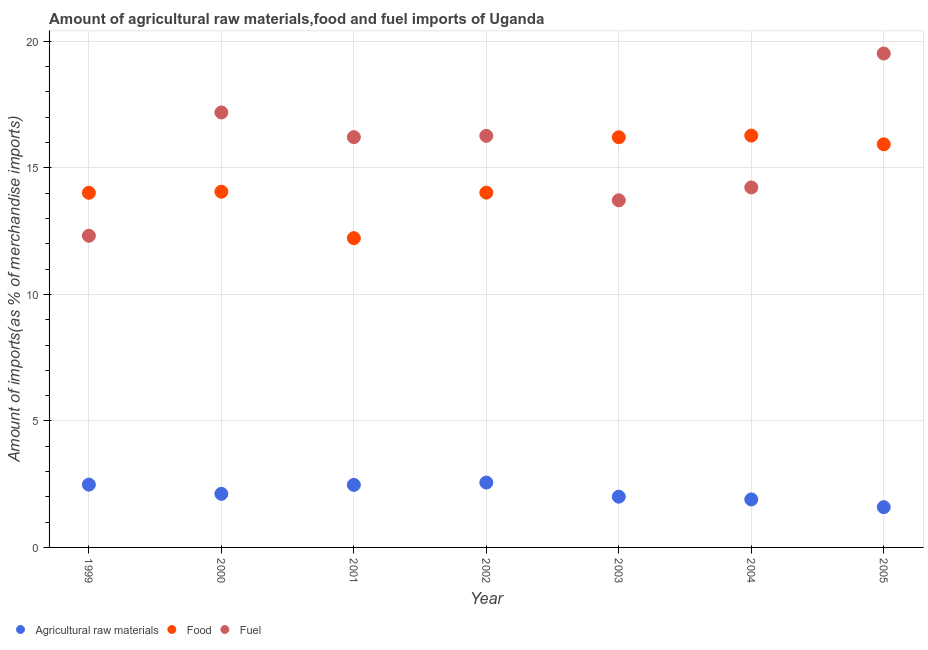Is the number of dotlines equal to the number of legend labels?
Keep it short and to the point. Yes. What is the percentage of fuel imports in 1999?
Offer a very short reply. 12.32. Across all years, what is the maximum percentage of food imports?
Offer a very short reply. 16.28. Across all years, what is the minimum percentage of fuel imports?
Your answer should be very brief. 12.32. In which year was the percentage of raw materials imports minimum?
Offer a terse response. 2005. What is the total percentage of fuel imports in the graph?
Ensure brevity in your answer.  109.46. What is the difference between the percentage of fuel imports in 1999 and that in 2001?
Give a very brief answer. -3.9. What is the difference between the percentage of raw materials imports in 2002 and the percentage of food imports in 2005?
Your answer should be very brief. -13.37. What is the average percentage of fuel imports per year?
Give a very brief answer. 15.64. In the year 2002, what is the difference between the percentage of raw materials imports and percentage of fuel imports?
Ensure brevity in your answer.  -13.7. In how many years, is the percentage of fuel imports greater than 15 %?
Your answer should be very brief. 4. What is the ratio of the percentage of fuel imports in 2000 to that in 2002?
Your answer should be very brief. 1.06. What is the difference between the highest and the second highest percentage of fuel imports?
Your answer should be compact. 2.33. What is the difference between the highest and the lowest percentage of food imports?
Your answer should be compact. 4.05. Is the sum of the percentage of fuel imports in 2000 and 2001 greater than the maximum percentage of raw materials imports across all years?
Your answer should be very brief. Yes. Is it the case that in every year, the sum of the percentage of raw materials imports and percentage of food imports is greater than the percentage of fuel imports?
Provide a short and direct response. No. Does the percentage of raw materials imports monotonically increase over the years?
Provide a succinct answer. No. Is the percentage of food imports strictly greater than the percentage of raw materials imports over the years?
Give a very brief answer. Yes. How many years are there in the graph?
Your answer should be compact. 7. What is the difference between two consecutive major ticks on the Y-axis?
Provide a short and direct response. 5. Are the values on the major ticks of Y-axis written in scientific E-notation?
Your answer should be compact. No. Does the graph contain any zero values?
Your answer should be compact. No. Where does the legend appear in the graph?
Keep it short and to the point. Bottom left. How are the legend labels stacked?
Give a very brief answer. Horizontal. What is the title of the graph?
Offer a terse response. Amount of agricultural raw materials,food and fuel imports of Uganda. What is the label or title of the X-axis?
Your answer should be very brief. Year. What is the label or title of the Y-axis?
Offer a terse response. Amount of imports(as % of merchandise imports). What is the Amount of imports(as % of merchandise imports) in Agricultural raw materials in 1999?
Make the answer very short. 2.48. What is the Amount of imports(as % of merchandise imports) of Food in 1999?
Ensure brevity in your answer.  14.02. What is the Amount of imports(as % of merchandise imports) of Fuel in 1999?
Ensure brevity in your answer.  12.32. What is the Amount of imports(as % of merchandise imports) of Agricultural raw materials in 2000?
Make the answer very short. 2.12. What is the Amount of imports(as % of merchandise imports) of Food in 2000?
Your answer should be very brief. 14.06. What is the Amount of imports(as % of merchandise imports) in Fuel in 2000?
Your answer should be very brief. 17.19. What is the Amount of imports(as % of merchandise imports) of Agricultural raw materials in 2001?
Keep it short and to the point. 2.47. What is the Amount of imports(as % of merchandise imports) of Food in 2001?
Keep it short and to the point. 12.22. What is the Amount of imports(as % of merchandise imports) in Fuel in 2001?
Keep it short and to the point. 16.22. What is the Amount of imports(as % of merchandise imports) in Agricultural raw materials in 2002?
Your answer should be very brief. 2.56. What is the Amount of imports(as % of merchandise imports) of Food in 2002?
Your answer should be very brief. 14.02. What is the Amount of imports(as % of merchandise imports) in Fuel in 2002?
Your response must be concise. 16.27. What is the Amount of imports(as % of merchandise imports) in Agricultural raw materials in 2003?
Your response must be concise. 2.01. What is the Amount of imports(as % of merchandise imports) in Food in 2003?
Your answer should be very brief. 16.21. What is the Amount of imports(as % of merchandise imports) in Fuel in 2003?
Give a very brief answer. 13.72. What is the Amount of imports(as % of merchandise imports) in Agricultural raw materials in 2004?
Make the answer very short. 1.9. What is the Amount of imports(as % of merchandise imports) in Food in 2004?
Give a very brief answer. 16.28. What is the Amount of imports(as % of merchandise imports) in Fuel in 2004?
Offer a very short reply. 14.23. What is the Amount of imports(as % of merchandise imports) of Agricultural raw materials in 2005?
Give a very brief answer. 1.59. What is the Amount of imports(as % of merchandise imports) of Food in 2005?
Provide a short and direct response. 15.93. What is the Amount of imports(as % of merchandise imports) of Fuel in 2005?
Your answer should be compact. 19.52. Across all years, what is the maximum Amount of imports(as % of merchandise imports) of Agricultural raw materials?
Offer a terse response. 2.56. Across all years, what is the maximum Amount of imports(as % of merchandise imports) in Food?
Provide a succinct answer. 16.28. Across all years, what is the maximum Amount of imports(as % of merchandise imports) in Fuel?
Make the answer very short. 19.52. Across all years, what is the minimum Amount of imports(as % of merchandise imports) in Agricultural raw materials?
Keep it short and to the point. 1.59. Across all years, what is the minimum Amount of imports(as % of merchandise imports) in Food?
Ensure brevity in your answer.  12.22. Across all years, what is the minimum Amount of imports(as % of merchandise imports) in Fuel?
Make the answer very short. 12.32. What is the total Amount of imports(as % of merchandise imports) in Agricultural raw materials in the graph?
Keep it short and to the point. 15.13. What is the total Amount of imports(as % of merchandise imports) of Food in the graph?
Provide a short and direct response. 102.74. What is the total Amount of imports(as % of merchandise imports) of Fuel in the graph?
Make the answer very short. 109.46. What is the difference between the Amount of imports(as % of merchandise imports) in Agricultural raw materials in 1999 and that in 2000?
Your response must be concise. 0.36. What is the difference between the Amount of imports(as % of merchandise imports) of Food in 1999 and that in 2000?
Make the answer very short. -0.04. What is the difference between the Amount of imports(as % of merchandise imports) in Fuel in 1999 and that in 2000?
Offer a terse response. -4.87. What is the difference between the Amount of imports(as % of merchandise imports) in Agricultural raw materials in 1999 and that in 2001?
Your answer should be very brief. 0.01. What is the difference between the Amount of imports(as % of merchandise imports) of Food in 1999 and that in 2001?
Your response must be concise. 1.79. What is the difference between the Amount of imports(as % of merchandise imports) of Fuel in 1999 and that in 2001?
Your response must be concise. -3.9. What is the difference between the Amount of imports(as % of merchandise imports) in Agricultural raw materials in 1999 and that in 2002?
Your response must be concise. -0.08. What is the difference between the Amount of imports(as % of merchandise imports) in Food in 1999 and that in 2002?
Offer a terse response. -0.01. What is the difference between the Amount of imports(as % of merchandise imports) in Fuel in 1999 and that in 2002?
Give a very brief answer. -3.95. What is the difference between the Amount of imports(as % of merchandise imports) of Agricultural raw materials in 1999 and that in 2003?
Provide a short and direct response. 0.48. What is the difference between the Amount of imports(as % of merchandise imports) in Food in 1999 and that in 2003?
Give a very brief answer. -2.19. What is the difference between the Amount of imports(as % of merchandise imports) of Fuel in 1999 and that in 2003?
Give a very brief answer. -1.4. What is the difference between the Amount of imports(as % of merchandise imports) in Agricultural raw materials in 1999 and that in 2004?
Keep it short and to the point. 0.58. What is the difference between the Amount of imports(as % of merchandise imports) of Food in 1999 and that in 2004?
Make the answer very short. -2.26. What is the difference between the Amount of imports(as % of merchandise imports) of Fuel in 1999 and that in 2004?
Make the answer very short. -1.91. What is the difference between the Amount of imports(as % of merchandise imports) in Agricultural raw materials in 1999 and that in 2005?
Keep it short and to the point. 0.89. What is the difference between the Amount of imports(as % of merchandise imports) in Food in 1999 and that in 2005?
Your response must be concise. -1.92. What is the difference between the Amount of imports(as % of merchandise imports) in Fuel in 1999 and that in 2005?
Provide a succinct answer. -7.2. What is the difference between the Amount of imports(as % of merchandise imports) of Agricultural raw materials in 2000 and that in 2001?
Your response must be concise. -0.35. What is the difference between the Amount of imports(as % of merchandise imports) of Food in 2000 and that in 2001?
Give a very brief answer. 1.83. What is the difference between the Amount of imports(as % of merchandise imports) of Fuel in 2000 and that in 2001?
Your response must be concise. 0.98. What is the difference between the Amount of imports(as % of merchandise imports) in Agricultural raw materials in 2000 and that in 2002?
Your response must be concise. -0.45. What is the difference between the Amount of imports(as % of merchandise imports) of Food in 2000 and that in 2002?
Give a very brief answer. 0.04. What is the difference between the Amount of imports(as % of merchandise imports) of Fuel in 2000 and that in 2002?
Provide a succinct answer. 0.92. What is the difference between the Amount of imports(as % of merchandise imports) of Agricultural raw materials in 2000 and that in 2003?
Offer a very short reply. 0.11. What is the difference between the Amount of imports(as % of merchandise imports) in Food in 2000 and that in 2003?
Give a very brief answer. -2.15. What is the difference between the Amount of imports(as % of merchandise imports) of Fuel in 2000 and that in 2003?
Offer a very short reply. 3.47. What is the difference between the Amount of imports(as % of merchandise imports) of Agricultural raw materials in 2000 and that in 2004?
Your response must be concise. 0.22. What is the difference between the Amount of imports(as % of merchandise imports) in Food in 2000 and that in 2004?
Your response must be concise. -2.22. What is the difference between the Amount of imports(as % of merchandise imports) in Fuel in 2000 and that in 2004?
Your answer should be compact. 2.96. What is the difference between the Amount of imports(as % of merchandise imports) of Agricultural raw materials in 2000 and that in 2005?
Make the answer very short. 0.53. What is the difference between the Amount of imports(as % of merchandise imports) of Food in 2000 and that in 2005?
Your answer should be very brief. -1.87. What is the difference between the Amount of imports(as % of merchandise imports) in Fuel in 2000 and that in 2005?
Your answer should be compact. -2.33. What is the difference between the Amount of imports(as % of merchandise imports) in Agricultural raw materials in 2001 and that in 2002?
Keep it short and to the point. -0.09. What is the difference between the Amount of imports(as % of merchandise imports) of Food in 2001 and that in 2002?
Offer a terse response. -1.8. What is the difference between the Amount of imports(as % of merchandise imports) in Fuel in 2001 and that in 2002?
Provide a succinct answer. -0.05. What is the difference between the Amount of imports(as % of merchandise imports) of Agricultural raw materials in 2001 and that in 2003?
Your answer should be very brief. 0.47. What is the difference between the Amount of imports(as % of merchandise imports) in Food in 2001 and that in 2003?
Provide a short and direct response. -3.99. What is the difference between the Amount of imports(as % of merchandise imports) in Fuel in 2001 and that in 2003?
Give a very brief answer. 2.5. What is the difference between the Amount of imports(as % of merchandise imports) in Agricultural raw materials in 2001 and that in 2004?
Ensure brevity in your answer.  0.57. What is the difference between the Amount of imports(as % of merchandise imports) in Food in 2001 and that in 2004?
Your response must be concise. -4.05. What is the difference between the Amount of imports(as % of merchandise imports) in Fuel in 2001 and that in 2004?
Give a very brief answer. 1.99. What is the difference between the Amount of imports(as % of merchandise imports) in Agricultural raw materials in 2001 and that in 2005?
Give a very brief answer. 0.88. What is the difference between the Amount of imports(as % of merchandise imports) in Food in 2001 and that in 2005?
Ensure brevity in your answer.  -3.71. What is the difference between the Amount of imports(as % of merchandise imports) in Fuel in 2001 and that in 2005?
Provide a short and direct response. -3.3. What is the difference between the Amount of imports(as % of merchandise imports) in Agricultural raw materials in 2002 and that in 2003?
Make the answer very short. 0.56. What is the difference between the Amount of imports(as % of merchandise imports) in Food in 2002 and that in 2003?
Ensure brevity in your answer.  -2.19. What is the difference between the Amount of imports(as % of merchandise imports) of Fuel in 2002 and that in 2003?
Your response must be concise. 2.55. What is the difference between the Amount of imports(as % of merchandise imports) in Agricultural raw materials in 2002 and that in 2004?
Offer a very short reply. 0.67. What is the difference between the Amount of imports(as % of merchandise imports) of Food in 2002 and that in 2004?
Offer a terse response. -2.25. What is the difference between the Amount of imports(as % of merchandise imports) in Fuel in 2002 and that in 2004?
Your response must be concise. 2.04. What is the difference between the Amount of imports(as % of merchandise imports) of Agricultural raw materials in 2002 and that in 2005?
Give a very brief answer. 0.97. What is the difference between the Amount of imports(as % of merchandise imports) in Food in 2002 and that in 2005?
Keep it short and to the point. -1.91. What is the difference between the Amount of imports(as % of merchandise imports) of Fuel in 2002 and that in 2005?
Give a very brief answer. -3.25. What is the difference between the Amount of imports(as % of merchandise imports) in Agricultural raw materials in 2003 and that in 2004?
Offer a very short reply. 0.11. What is the difference between the Amount of imports(as % of merchandise imports) of Food in 2003 and that in 2004?
Provide a short and direct response. -0.07. What is the difference between the Amount of imports(as % of merchandise imports) of Fuel in 2003 and that in 2004?
Offer a very short reply. -0.51. What is the difference between the Amount of imports(as % of merchandise imports) in Agricultural raw materials in 2003 and that in 2005?
Your answer should be compact. 0.41. What is the difference between the Amount of imports(as % of merchandise imports) in Food in 2003 and that in 2005?
Give a very brief answer. 0.28. What is the difference between the Amount of imports(as % of merchandise imports) in Fuel in 2003 and that in 2005?
Ensure brevity in your answer.  -5.8. What is the difference between the Amount of imports(as % of merchandise imports) of Agricultural raw materials in 2004 and that in 2005?
Offer a terse response. 0.31. What is the difference between the Amount of imports(as % of merchandise imports) in Food in 2004 and that in 2005?
Ensure brevity in your answer.  0.35. What is the difference between the Amount of imports(as % of merchandise imports) of Fuel in 2004 and that in 2005?
Your answer should be very brief. -5.29. What is the difference between the Amount of imports(as % of merchandise imports) in Agricultural raw materials in 1999 and the Amount of imports(as % of merchandise imports) in Food in 2000?
Make the answer very short. -11.58. What is the difference between the Amount of imports(as % of merchandise imports) in Agricultural raw materials in 1999 and the Amount of imports(as % of merchandise imports) in Fuel in 2000?
Your answer should be compact. -14.71. What is the difference between the Amount of imports(as % of merchandise imports) of Food in 1999 and the Amount of imports(as % of merchandise imports) of Fuel in 2000?
Your answer should be very brief. -3.18. What is the difference between the Amount of imports(as % of merchandise imports) of Agricultural raw materials in 1999 and the Amount of imports(as % of merchandise imports) of Food in 2001?
Provide a succinct answer. -9.74. What is the difference between the Amount of imports(as % of merchandise imports) in Agricultural raw materials in 1999 and the Amount of imports(as % of merchandise imports) in Fuel in 2001?
Your answer should be very brief. -13.73. What is the difference between the Amount of imports(as % of merchandise imports) of Food in 1999 and the Amount of imports(as % of merchandise imports) of Fuel in 2001?
Provide a succinct answer. -2.2. What is the difference between the Amount of imports(as % of merchandise imports) of Agricultural raw materials in 1999 and the Amount of imports(as % of merchandise imports) of Food in 2002?
Provide a succinct answer. -11.54. What is the difference between the Amount of imports(as % of merchandise imports) in Agricultural raw materials in 1999 and the Amount of imports(as % of merchandise imports) in Fuel in 2002?
Your response must be concise. -13.78. What is the difference between the Amount of imports(as % of merchandise imports) in Food in 1999 and the Amount of imports(as % of merchandise imports) in Fuel in 2002?
Provide a short and direct response. -2.25. What is the difference between the Amount of imports(as % of merchandise imports) of Agricultural raw materials in 1999 and the Amount of imports(as % of merchandise imports) of Food in 2003?
Your answer should be very brief. -13.73. What is the difference between the Amount of imports(as % of merchandise imports) in Agricultural raw materials in 1999 and the Amount of imports(as % of merchandise imports) in Fuel in 2003?
Your answer should be very brief. -11.24. What is the difference between the Amount of imports(as % of merchandise imports) in Food in 1999 and the Amount of imports(as % of merchandise imports) in Fuel in 2003?
Your answer should be compact. 0.3. What is the difference between the Amount of imports(as % of merchandise imports) in Agricultural raw materials in 1999 and the Amount of imports(as % of merchandise imports) in Food in 2004?
Your answer should be compact. -13.79. What is the difference between the Amount of imports(as % of merchandise imports) in Agricultural raw materials in 1999 and the Amount of imports(as % of merchandise imports) in Fuel in 2004?
Provide a succinct answer. -11.75. What is the difference between the Amount of imports(as % of merchandise imports) in Food in 1999 and the Amount of imports(as % of merchandise imports) in Fuel in 2004?
Make the answer very short. -0.21. What is the difference between the Amount of imports(as % of merchandise imports) of Agricultural raw materials in 1999 and the Amount of imports(as % of merchandise imports) of Food in 2005?
Give a very brief answer. -13.45. What is the difference between the Amount of imports(as % of merchandise imports) of Agricultural raw materials in 1999 and the Amount of imports(as % of merchandise imports) of Fuel in 2005?
Ensure brevity in your answer.  -17.04. What is the difference between the Amount of imports(as % of merchandise imports) in Food in 1999 and the Amount of imports(as % of merchandise imports) in Fuel in 2005?
Your response must be concise. -5.5. What is the difference between the Amount of imports(as % of merchandise imports) of Agricultural raw materials in 2000 and the Amount of imports(as % of merchandise imports) of Food in 2001?
Give a very brief answer. -10.11. What is the difference between the Amount of imports(as % of merchandise imports) in Agricultural raw materials in 2000 and the Amount of imports(as % of merchandise imports) in Fuel in 2001?
Your response must be concise. -14.1. What is the difference between the Amount of imports(as % of merchandise imports) in Food in 2000 and the Amount of imports(as % of merchandise imports) in Fuel in 2001?
Provide a succinct answer. -2.16. What is the difference between the Amount of imports(as % of merchandise imports) of Agricultural raw materials in 2000 and the Amount of imports(as % of merchandise imports) of Food in 2002?
Provide a succinct answer. -11.9. What is the difference between the Amount of imports(as % of merchandise imports) of Agricultural raw materials in 2000 and the Amount of imports(as % of merchandise imports) of Fuel in 2002?
Make the answer very short. -14.15. What is the difference between the Amount of imports(as % of merchandise imports) in Food in 2000 and the Amount of imports(as % of merchandise imports) in Fuel in 2002?
Your response must be concise. -2.21. What is the difference between the Amount of imports(as % of merchandise imports) in Agricultural raw materials in 2000 and the Amount of imports(as % of merchandise imports) in Food in 2003?
Ensure brevity in your answer.  -14.09. What is the difference between the Amount of imports(as % of merchandise imports) of Agricultural raw materials in 2000 and the Amount of imports(as % of merchandise imports) of Fuel in 2003?
Offer a terse response. -11.6. What is the difference between the Amount of imports(as % of merchandise imports) of Food in 2000 and the Amount of imports(as % of merchandise imports) of Fuel in 2003?
Offer a very short reply. 0.34. What is the difference between the Amount of imports(as % of merchandise imports) of Agricultural raw materials in 2000 and the Amount of imports(as % of merchandise imports) of Food in 2004?
Make the answer very short. -14.16. What is the difference between the Amount of imports(as % of merchandise imports) of Agricultural raw materials in 2000 and the Amount of imports(as % of merchandise imports) of Fuel in 2004?
Offer a terse response. -12.11. What is the difference between the Amount of imports(as % of merchandise imports) in Food in 2000 and the Amount of imports(as % of merchandise imports) in Fuel in 2004?
Offer a very short reply. -0.17. What is the difference between the Amount of imports(as % of merchandise imports) in Agricultural raw materials in 2000 and the Amount of imports(as % of merchandise imports) in Food in 2005?
Keep it short and to the point. -13.81. What is the difference between the Amount of imports(as % of merchandise imports) of Agricultural raw materials in 2000 and the Amount of imports(as % of merchandise imports) of Fuel in 2005?
Your answer should be very brief. -17.4. What is the difference between the Amount of imports(as % of merchandise imports) of Food in 2000 and the Amount of imports(as % of merchandise imports) of Fuel in 2005?
Your answer should be very brief. -5.46. What is the difference between the Amount of imports(as % of merchandise imports) in Agricultural raw materials in 2001 and the Amount of imports(as % of merchandise imports) in Food in 2002?
Offer a very short reply. -11.55. What is the difference between the Amount of imports(as % of merchandise imports) in Agricultural raw materials in 2001 and the Amount of imports(as % of merchandise imports) in Fuel in 2002?
Provide a succinct answer. -13.79. What is the difference between the Amount of imports(as % of merchandise imports) in Food in 2001 and the Amount of imports(as % of merchandise imports) in Fuel in 2002?
Offer a very short reply. -4.04. What is the difference between the Amount of imports(as % of merchandise imports) of Agricultural raw materials in 2001 and the Amount of imports(as % of merchandise imports) of Food in 2003?
Your answer should be very brief. -13.74. What is the difference between the Amount of imports(as % of merchandise imports) of Agricultural raw materials in 2001 and the Amount of imports(as % of merchandise imports) of Fuel in 2003?
Offer a terse response. -11.25. What is the difference between the Amount of imports(as % of merchandise imports) in Food in 2001 and the Amount of imports(as % of merchandise imports) in Fuel in 2003?
Keep it short and to the point. -1.5. What is the difference between the Amount of imports(as % of merchandise imports) of Agricultural raw materials in 2001 and the Amount of imports(as % of merchandise imports) of Food in 2004?
Give a very brief answer. -13.8. What is the difference between the Amount of imports(as % of merchandise imports) in Agricultural raw materials in 2001 and the Amount of imports(as % of merchandise imports) in Fuel in 2004?
Provide a succinct answer. -11.76. What is the difference between the Amount of imports(as % of merchandise imports) in Food in 2001 and the Amount of imports(as % of merchandise imports) in Fuel in 2004?
Offer a very short reply. -2. What is the difference between the Amount of imports(as % of merchandise imports) in Agricultural raw materials in 2001 and the Amount of imports(as % of merchandise imports) in Food in 2005?
Keep it short and to the point. -13.46. What is the difference between the Amount of imports(as % of merchandise imports) of Agricultural raw materials in 2001 and the Amount of imports(as % of merchandise imports) of Fuel in 2005?
Ensure brevity in your answer.  -17.05. What is the difference between the Amount of imports(as % of merchandise imports) of Food in 2001 and the Amount of imports(as % of merchandise imports) of Fuel in 2005?
Provide a short and direct response. -7.3. What is the difference between the Amount of imports(as % of merchandise imports) of Agricultural raw materials in 2002 and the Amount of imports(as % of merchandise imports) of Food in 2003?
Your response must be concise. -13.65. What is the difference between the Amount of imports(as % of merchandise imports) of Agricultural raw materials in 2002 and the Amount of imports(as % of merchandise imports) of Fuel in 2003?
Your answer should be very brief. -11.15. What is the difference between the Amount of imports(as % of merchandise imports) in Food in 2002 and the Amount of imports(as % of merchandise imports) in Fuel in 2003?
Ensure brevity in your answer.  0.3. What is the difference between the Amount of imports(as % of merchandise imports) in Agricultural raw materials in 2002 and the Amount of imports(as % of merchandise imports) in Food in 2004?
Provide a short and direct response. -13.71. What is the difference between the Amount of imports(as % of merchandise imports) of Agricultural raw materials in 2002 and the Amount of imports(as % of merchandise imports) of Fuel in 2004?
Offer a very short reply. -11.66. What is the difference between the Amount of imports(as % of merchandise imports) in Food in 2002 and the Amount of imports(as % of merchandise imports) in Fuel in 2004?
Provide a succinct answer. -0.21. What is the difference between the Amount of imports(as % of merchandise imports) in Agricultural raw materials in 2002 and the Amount of imports(as % of merchandise imports) in Food in 2005?
Offer a very short reply. -13.37. What is the difference between the Amount of imports(as % of merchandise imports) of Agricultural raw materials in 2002 and the Amount of imports(as % of merchandise imports) of Fuel in 2005?
Offer a very short reply. -16.96. What is the difference between the Amount of imports(as % of merchandise imports) of Food in 2002 and the Amount of imports(as % of merchandise imports) of Fuel in 2005?
Offer a terse response. -5.5. What is the difference between the Amount of imports(as % of merchandise imports) in Agricultural raw materials in 2003 and the Amount of imports(as % of merchandise imports) in Food in 2004?
Your answer should be very brief. -14.27. What is the difference between the Amount of imports(as % of merchandise imports) in Agricultural raw materials in 2003 and the Amount of imports(as % of merchandise imports) in Fuel in 2004?
Provide a succinct answer. -12.22. What is the difference between the Amount of imports(as % of merchandise imports) of Food in 2003 and the Amount of imports(as % of merchandise imports) of Fuel in 2004?
Offer a very short reply. 1.98. What is the difference between the Amount of imports(as % of merchandise imports) in Agricultural raw materials in 2003 and the Amount of imports(as % of merchandise imports) in Food in 2005?
Your answer should be very brief. -13.93. What is the difference between the Amount of imports(as % of merchandise imports) in Agricultural raw materials in 2003 and the Amount of imports(as % of merchandise imports) in Fuel in 2005?
Your answer should be compact. -17.52. What is the difference between the Amount of imports(as % of merchandise imports) in Food in 2003 and the Amount of imports(as % of merchandise imports) in Fuel in 2005?
Offer a very short reply. -3.31. What is the difference between the Amount of imports(as % of merchandise imports) in Agricultural raw materials in 2004 and the Amount of imports(as % of merchandise imports) in Food in 2005?
Your response must be concise. -14.03. What is the difference between the Amount of imports(as % of merchandise imports) of Agricultural raw materials in 2004 and the Amount of imports(as % of merchandise imports) of Fuel in 2005?
Provide a short and direct response. -17.62. What is the difference between the Amount of imports(as % of merchandise imports) of Food in 2004 and the Amount of imports(as % of merchandise imports) of Fuel in 2005?
Keep it short and to the point. -3.24. What is the average Amount of imports(as % of merchandise imports) of Agricultural raw materials per year?
Ensure brevity in your answer.  2.16. What is the average Amount of imports(as % of merchandise imports) in Food per year?
Your answer should be very brief. 14.68. What is the average Amount of imports(as % of merchandise imports) of Fuel per year?
Provide a succinct answer. 15.64. In the year 1999, what is the difference between the Amount of imports(as % of merchandise imports) of Agricultural raw materials and Amount of imports(as % of merchandise imports) of Food?
Your answer should be very brief. -11.53. In the year 1999, what is the difference between the Amount of imports(as % of merchandise imports) of Agricultural raw materials and Amount of imports(as % of merchandise imports) of Fuel?
Offer a terse response. -9.84. In the year 1999, what is the difference between the Amount of imports(as % of merchandise imports) in Food and Amount of imports(as % of merchandise imports) in Fuel?
Your answer should be compact. 1.7. In the year 2000, what is the difference between the Amount of imports(as % of merchandise imports) in Agricultural raw materials and Amount of imports(as % of merchandise imports) in Food?
Offer a very short reply. -11.94. In the year 2000, what is the difference between the Amount of imports(as % of merchandise imports) in Agricultural raw materials and Amount of imports(as % of merchandise imports) in Fuel?
Offer a very short reply. -15.07. In the year 2000, what is the difference between the Amount of imports(as % of merchandise imports) in Food and Amount of imports(as % of merchandise imports) in Fuel?
Keep it short and to the point. -3.13. In the year 2001, what is the difference between the Amount of imports(as % of merchandise imports) in Agricultural raw materials and Amount of imports(as % of merchandise imports) in Food?
Provide a succinct answer. -9.75. In the year 2001, what is the difference between the Amount of imports(as % of merchandise imports) of Agricultural raw materials and Amount of imports(as % of merchandise imports) of Fuel?
Your response must be concise. -13.74. In the year 2001, what is the difference between the Amount of imports(as % of merchandise imports) in Food and Amount of imports(as % of merchandise imports) in Fuel?
Provide a short and direct response. -3.99. In the year 2002, what is the difference between the Amount of imports(as % of merchandise imports) in Agricultural raw materials and Amount of imports(as % of merchandise imports) in Food?
Your answer should be very brief. -11.46. In the year 2002, what is the difference between the Amount of imports(as % of merchandise imports) of Agricultural raw materials and Amount of imports(as % of merchandise imports) of Fuel?
Offer a very short reply. -13.7. In the year 2002, what is the difference between the Amount of imports(as % of merchandise imports) of Food and Amount of imports(as % of merchandise imports) of Fuel?
Provide a succinct answer. -2.24. In the year 2003, what is the difference between the Amount of imports(as % of merchandise imports) of Agricultural raw materials and Amount of imports(as % of merchandise imports) of Food?
Offer a terse response. -14.2. In the year 2003, what is the difference between the Amount of imports(as % of merchandise imports) of Agricultural raw materials and Amount of imports(as % of merchandise imports) of Fuel?
Provide a short and direct response. -11.71. In the year 2003, what is the difference between the Amount of imports(as % of merchandise imports) of Food and Amount of imports(as % of merchandise imports) of Fuel?
Your answer should be compact. 2.49. In the year 2004, what is the difference between the Amount of imports(as % of merchandise imports) in Agricultural raw materials and Amount of imports(as % of merchandise imports) in Food?
Provide a succinct answer. -14.38. In the year 2004, what is the difference between the Amount of imports(as % of merchandise imports) in Agricultural raw materials and Amount of imports(as % of merchandise imports) in Fuel?
Keep it short and to the point. -12.33. In the year 2004, what is the difference between the Amount of imports(as % of merchandise imports) in Food and Amount of imports(as % of merchandise imports) in Fuel?
Provide a succinct answer. 2.05. In the year 2005, what is the difference between the Amount of imports(as % of merchandise imports) of Agricultural raw materials and Amount of imports(as % of merchandise imports) of Food?
Give a very brief answer. -14.34. In the year 2005, what is the difference between the Amount of imports(as % of merchandise imports) in Agricultural raw materials and Amount of imports(as % of merchandise imports) in Fuel?
Ensure brevity in your answer.  -17.93. In the year 2005, what is the difference between the Amount of imports(as % of merchandise imports) of Food and Amount of imports(as % of merchandise imports) of Fuel?
Offer a terse response. -3.59. What is the ratio of the Amount of imports(as % of merchandise imports) in Agricultural raw materials in 1999 to that in 2000?
Keep it short and to the point. 1.17. What is the ratio of the Amount of imports(as % of merchandise imports) of Food in 1999 to that in 2000?
Keep it short and to the point. 1. What is the ratio of the Amount of imports(as % of merchandise imports) of Fuel in 1999 to that in 2000?
Keep it short and to the point. 0.72. What is the ratio of the Amount of imports(as % of merchandise imports) of Food in 1999 to that in 2001?
Provide a succinct answer. 1.15. What is the ratio of the Amount of imports(as % of merchandise imports) of Fuel in 1999 to that in 2001?
Ensure brevity in your answer.  0.76. What is the ratio of the Amount of imports(as % of merchandise imports) in Agricultural raw materials in 1999 to that in 2002?
Give a very brief answer. 0.97. What is the ratio of the Amount of imports(as % of merchandise imports) in Fuel in 1999 to that in 2002?
Offer a terse response. 0.76. What is the ratio of the Amount of imports(as % of merchandise imports) in Agricultural raw materials in 1999 to that in 2003?
Offer a very short reply. 1.24. What is the ratio of the Amount of imports(as % of merchandise imports) in Food in 1999 to that in 2003?
Your answer should be very brief. 0.86. What is the ratio of the Amount of imports(as % of merchandise imports) in Fuel in 1999 to that in 2003?
Keep it short and to the point. 0.9. What is the ratio of the Amount of imports(as % of merchandise imports) in Agricultural raw materials in 1999 to that in 2004?
Your response must be concise. 1.31. What is the ratio of the Amount of imports(as % of merchandise imports) in Food in 1999 to that in 2004?
Your answer should be compact. 0.86. What is the ratio of the Amount of imports(as % of merchandise imports) of Fuel in 1999 to that in 2004?
Your response must be concise. 0.87. What is the ratio of the Amount of imports(as % of merchandise imports) in Agricultural raw materials in 1999 to that in 2005?
Give a very brief answer. 1.56. What is the ratio of the Amount of imports(as % of merchandise imports) in Food in 1999 to that in 2005?
Keep it short and to the point. 0.88. What is the ratio of the Amount of imports(as % of merchandise imports) of Fuel in 1999 to that in 2005?
Ensure brevity in your answer.  0.63. What is the ratio of the Amount of imports(as % of merchandise imports) of Agricultural raw materials in 2000 to that in 2001?
Your answer should be very brief. 0.86. What is the ratio of the Amount of imports(as % of merchandise imports) in Food in 2000 to that in 2001?
Ensure brevity in your answer.  1.15. What is the ratio of the Amount of imports(as % of merchandise imports) of Fuel in 2000 to that in 2001?
Provide a short and direct response. 1.06. What is the ratio of the Amount of imports(as % of merchandise imports) of Agricultural raw materials in 2000 to that in 2002?
Make the answer very short. 0.83. What is the ratio of the Amount of imports(as % of merchandise imports) in Fuel in 2000 to that in 2002?
Keep it short and to the point. 1.06. What is the ratio of the Amount of imports(as % of merchandise imports) of Agricultural raw materials in 2000 to that in 2003?
Keep it short and to the point. 1.06. What is the ratio of the Amount of imports(as % of merchandise imports) in Food in 2000 to that in 2003?
Your answer should be compact. 0.87. What is the ratio of the Amount of imports(as % of merchandise imports) in Fuel in 2000 to that in 2003?
Your response must be concise. 1.25. What is the ratio of the Amount of imports(as % of merchandise imports) of Agricultural raw materials in 2000 to that in 2004?
Provide a succinct answer. 1.12. What is the ratio of the Amount of imports(as % of merchandise imports) of Food in 2000 to that in 2004?
Your response must be concise. 0.86. What is the ratio of the Amount of imports(as % of merchandise imports) in Fuel in 2000 to that in 2004?
Your answer should be very brief. 1.21. What is the ratio of the Amount of imports(as % of merchandise imports) of Agricultural raw materials in 2000 to that in 2005?
Provide a short and direct response. 1.33. What is the ratio of the Amount of imports(as % of merchandise imports) in Food in 2000 to that in 2005?
Provide a succinct answer. 0.88. What is the ratio of the Amount of imports(as % of merchandise imports) of Fuel in 2000 to that in 2005?
Provide a succinct answer. 0.88. What is the ratio of the Amount of imports(as % of merchandise imports) in Agricultural raw materials in 2001 to that in 2002?
Offer a very short reply. 0.96. What is the ratio of the Amount of imports(as % of merchandise imports) in Food in 2001 to that in 2002?
Your response must be concise. 0.87. What is the ratio of the Amount of imports(as % of merchandise imports) of Agricultural raw materials in 2001 to that in 2003?
Your answer should be very brief. 1.23. What is the ratio of the Amount of imports(as % of merchandise imports) of Food in 2001 to that in 2003?
Offer a very short reply. 0.75. What is the ratio of the Amount of imports(as % of merchandise imports) of Fuel in 2001 to that in 2003?
Provide a short and direct response. 1.18. What is the ratio of the Amount of imports(as % of merchandise imports) of Agricultural raw materials in 2001 to that in 2004?
Give a very brief answer. 1.3. What is the ratio of the Amount of imports(as % of merchandise imports) of Food in 2001 to that in 2004?
Your answer should be very brief. 0.75. What is the ratio of the Amount of imports(as % of merchandise imports) of Fuel in 2001 to that in 2004?
Your answer should be compact. 1.14. What is the ratio of the Amount of imports(as % of merchandise imports) in Agricultural raw materials in 2001 to that in 2005?
Offer a terse response. 1.55. What is the ratio of the Amount of imports(as % of merchandise imports) in Food in 2001 to that in 2005?
Provide a succinct answer. 0.77. What is the ratio of the Amount of imports(as % of merchandise imports) in Fuel in 2001 to that in 2005?
Give a very brief answer. 0.83. What is the ratio of the Amount of imports(as % of merchandise imports) in Agricultural raw materials in 2002 to that in 2003?
Give a very brief answer. 1.28. What is the ratio of the Amount of imports(as % of merchandise imports) in Food in 2002 to that in 2003?
Offer a very short reply. 0.86. What is the ratio of the Amount of imports(as % of merchandise imports) of Fuel in 2002 to that in 2003?
Offer a very short reply. 1.19. What is the ratio of the Amount of imports(as % of merchandise imports) in Agricultural raw materials in 2002 to that in 2004?
Your answer should be very brief. 1.35. What is the ratio of the Amount of imports(as % of merchandise imports) of Food in 2002 to that in 2004?
Keep it short and to the point. 0.86. What is the ratio of the Amount of imports(as % of merchandise imports) in Fuel in 2002 to that in 2004?
Offer a very short reply. 1.14. What is the ratio of the Amount of imports(as % of merchandise imports) of Agricultural raw materials in 2002 to that in 2005?
Keep it short and to the point. 1.61. What is the ratio of the Amount of imports(as % of merchandise imports) in Food in 2002 to that in 2005?
Your answer should be compact. 0.88. What is the ratio of the Amount of imports(as % of merchandise imports) of Agricultural raw materials in 2003 to that in 2004?
Your response must be concise. 1.06. What is the ratio of the Amount of imports(as % of merchandise imports) of Food in 2003 to that in 2004?
Ensure brevity in your answer.  1. What is the ratio of the Amount of imports(as % of merchandise imports) of Fuel in 2003 to that in 2004?
Offer a very short reply. 0.96. What is the ratio of the Amount of imports(as % of merchandise imports) in Agricultural raw materials in 2003 to that in 2005?
Provide a succinct answer. 1.26. What is the ratio of the Amount of imports(as % of merchandise imports) of Food in 2003 to that in 2005?
Make the answer very short. 1.02. What is the ratio of the Amount of imports(as % of merchandise imports) of Fuel in 2003 to that in 2005?
Make the answer very short. 0.7. What is the ratio of the Amount of imports(as % of merchandise imports) of Agricultural raw materials in 2004 to that in 2005?
Provide a succinct answer. 1.19. What is the ratio of the Amount of imports(as % of merchandise imports) of Food in 2004 to that in 2005?
Ensure brevity in your answer.  1.02. What is the ratio of the Amount of imports(as % of merchandise imports) of Fuel in 2004 to that in 2005?
Make the answer very short. 0.73. What is the difference between the highest and the second highest Amount of imports(as % of merchandise imports) of Agricultural raw materials?
Your answer should be compact. 0.08. What is the difference between the highest and the second highest Amount of imports(as % of merchandise imports) of Food?
Your answer should be very brief. 0.07. What is the difference between the highest and the second highest Amount of imports(as % of merchandise imports) in Fuel?
Provide a succinct answer. 2.33. What is the difference between the highest and the lowest Amount of imports(as % of merchandise imports) of Agricultural raw materials?
Make the answer very short. 0.97. What is the difference between the highest and the lowest Amount of imports(as % of merchandise imports) of Food?
Keep it short and to the point. 4.05. What is the difference between the highest and the lowest Amount of imports(as % of merchandise imports) of Fuel?
Your answer should be very brief. 7.2. 